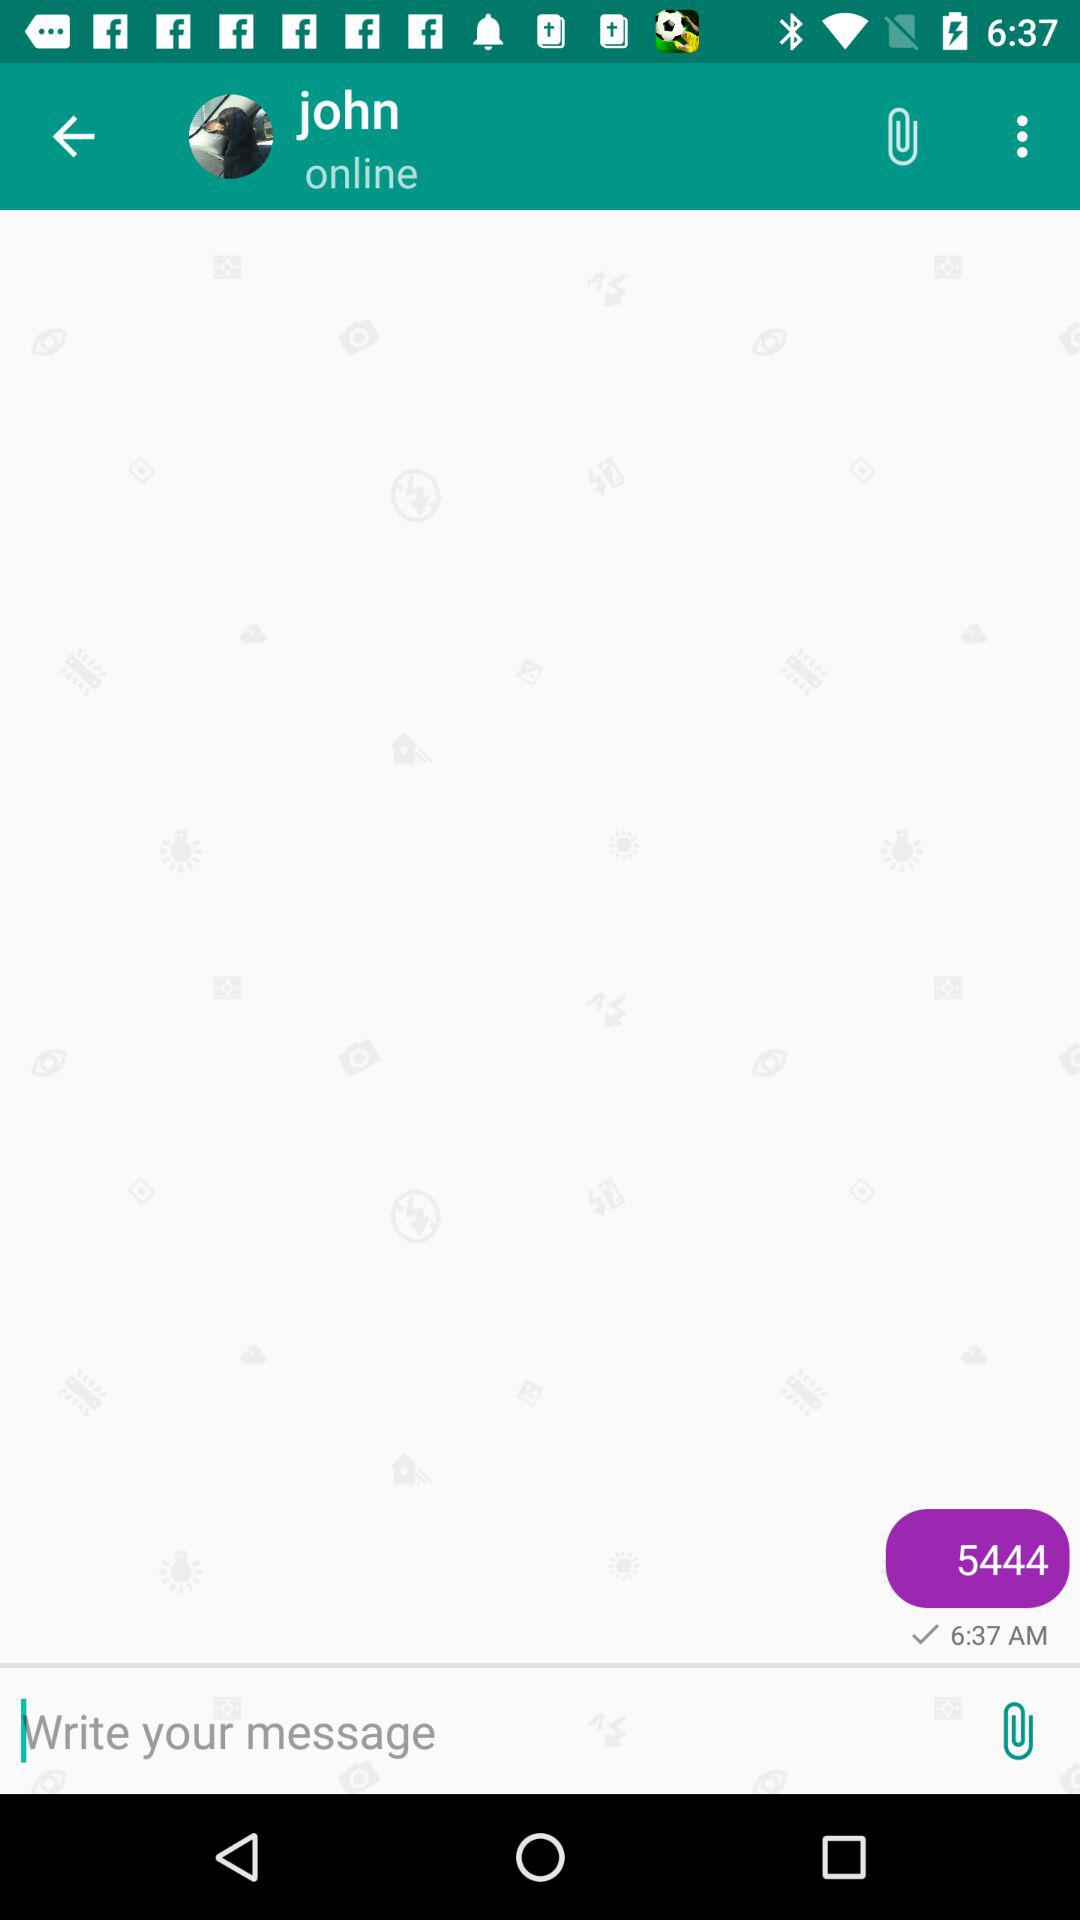What is the name of the person with whom I am chatting? The name of the person is John. 